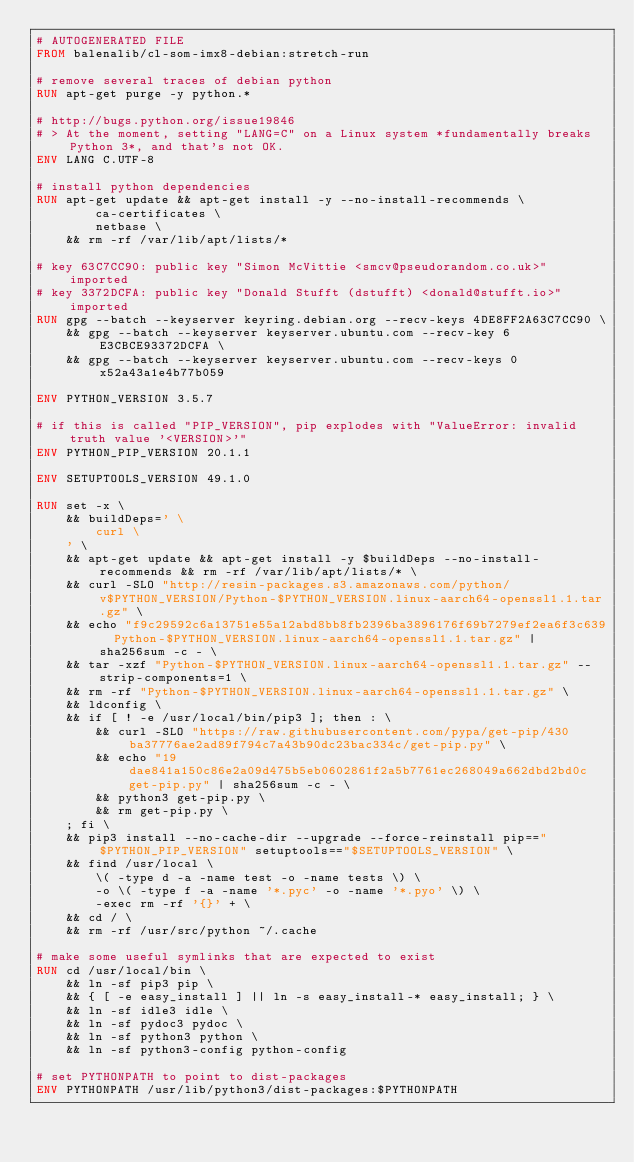Convert code to text. <code><loc_0><loc_0><loc_500><loc_500><_Dockerfile_># AUTOGENERATED FILE
FROM balenalib/cl-som-imx8-debian:stretch-run

# remove several traces of debian python
RUN apt-get purge -y python.*

# http://bugs.python.org/issue19846
# > At the moment, setting "LANG=C" on a Linux system *fundamentally breaks Python 3*, and that's not OK.
ENV LANG C.UTF-8

# install python dependencies
RUN apt-get update && apt-get install -y --no-install-recommends \
		ca-certificates \
		netbase \
	&& rm -rf /var/lib/apt/lists/*

# key 63C7CC90: public key "Simon McVittie <smcv@pseudorandom.co.uk>" imported
# key 3372DCFA: public key "Donald Stufft (dstufft) <donald@stufft.io>" imported
RUN gpg --batch --keyserver keyring.debian.org --recv-keys 4DE8FF2A63C7CC90 \
	&& gpg --batch --keyserver keyserver.ubuntu.com --recv-key 6E3CBCE93372DCFA \
	&& gpg --batch --keyserver keyserver.ubuntu.com --recv-keys 0x52a43a1e4b77b059

ENV PYTHON_VERSION 3.5.7

# if this is called "PIP_VERSION", pip explodes with "ValueError: invalid truth value '<VERSION>'"
ENV PYTHON_PIP_VERSION 20.1.1

ENV SETUPTOOLS_VERSION 49.1.0

RUN set -x \
	&& buildDeps=' \
		curl \
	' \
	&& apt-get update && apt-get install -y $buildDeps --no-install-recommends && rm -rf /var/lib/apt/lists/* \
	&& curl -SLO "http://resin-packages.s3.amazonaws.com/python/v$PYTHON_VERSION/Python-$PYTHON_VERSION.linux-aarch64-openssl1.1.tar.gz" \
	&& echo "f9c29592c6a13751e55a12abd8bb8fb2396ba3896176f69b7279ef2ea6f3c639  Python-$PYTHON_VERSION.linux-aarch64-openssl1.1.tar.gz" | sha256sum -c - \
	&& tar -xzf "Python-$PYTHON_VERSION.linux-aarch64-openssl1.1.tar.gz" --strip-components=1 \
	&& rm -rf "Python-$PYTHON_VERSION.linux-aarch64-openssl1.1.tar.gz" \
	&& ldconfig \
	&& if [ ! -e /usr/local/bin/pip3 ]; then : \
		&& curl -SLO "https://raw.githubusercontent.com/pypa/get-pip/430ba37776ae2ad89f794c7a43b90dc23bac334c/get-pip.py" \
		&& echo "19dae841a150c86e2a09d475b5eb0602861f2a5b7761ec268049a662dbd2bd0c  get-pip.py" | sha256sum -c - \
		&& python3 get-pip.py \
		&& rm get-pip.py \
	; fi \
	&& pip3 install --no-cache-dir --upgrade --force-reinstall pip=="$PYTHON_PIP_VERSION" setuptools=="$SETUPTOOLS_VERSION" \
	&& find /usr/local \
		\( -type d -a -name test -o -name tests \) \
		-o \( -type f -a -name '*.pyc' -o -name '*.pyo' \) \
		-exec rm -rf '{}' + \
	&& cd / \
	&& rm -rf /usr/src/python ~/.cache

# make some useful symlinks that are expected to exist
RUN cd /usr/local/bin \
	&& ln -sf pip3 pip \
	&& { [ -e easy_install ] || ln -s easy_install-* easy_install; } \
	&& ln -sf idle3 idle \
	&& ln -sf pydoc3 pydoc \
	&& ln -sf python3 python \
	&& ln -sf python3-config python-config

# set PYTHONPATH to point to dist-packages
ENV PYTHONPATH /usr/lib/python3/dist-packages:$PYTHONPATH
</code> 